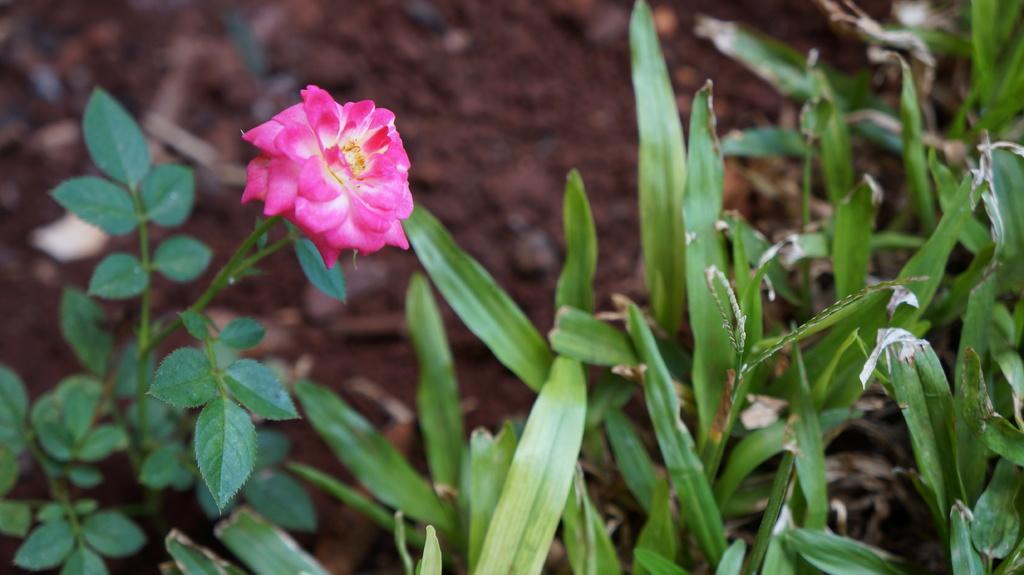Describe this image in one or two sentences. In this image we can see a flower, there are plants, and the background is blurred. 